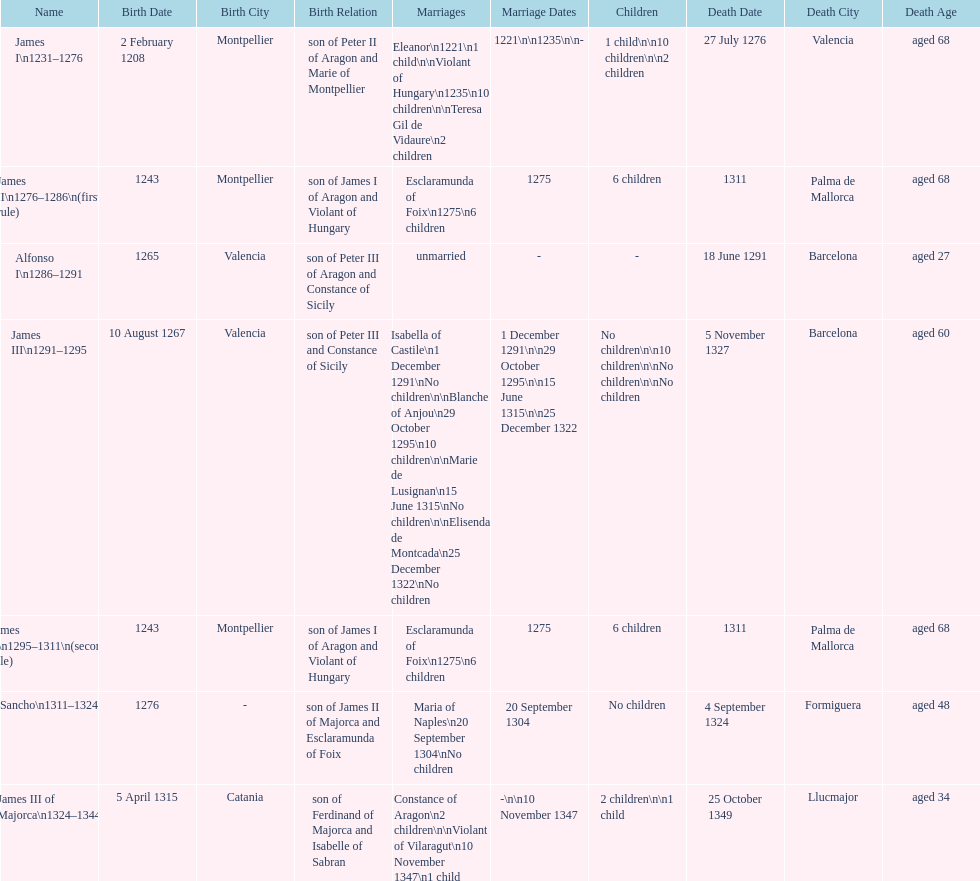Which monarch is listed first? James I 1231-1276. 